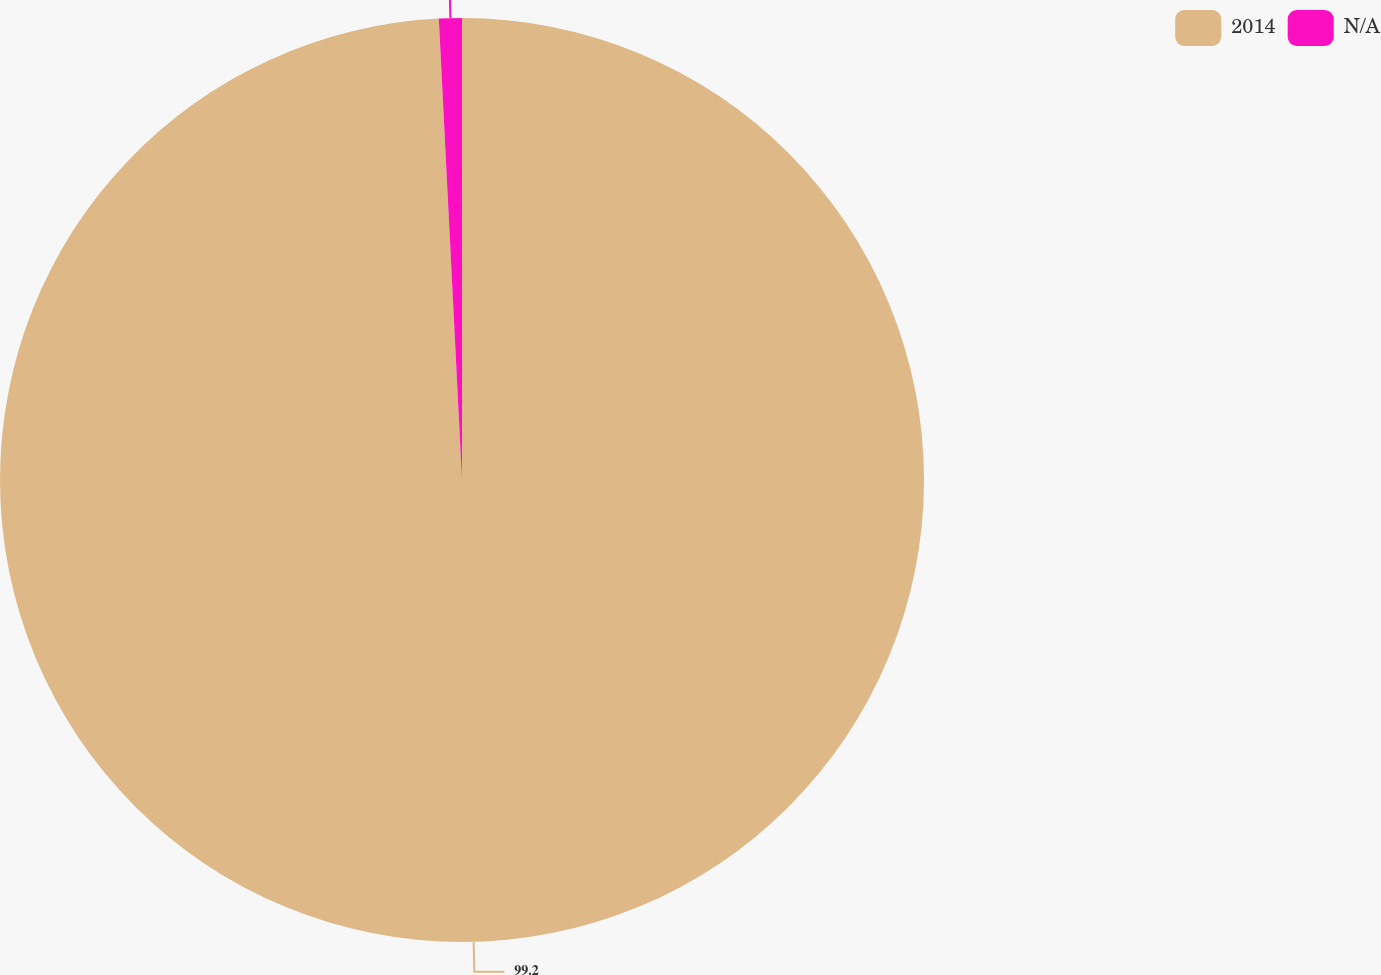Convert chart. <chart><loc_0><loc_0><loc_500><loc_500><pie_chart><fcel>2014<fcel>N/A<nl><fcel>99.2%<fcel>0.8%<nl></chart> 